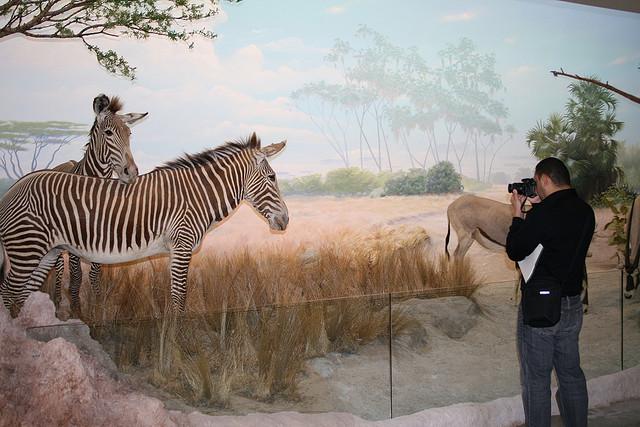What is the photographer taking a picture of?
Quick response, please. Zebras. Are the animals real?
Keep it brief. No. What is the photographer holding under his arm?
Concise answer only. Paper. 